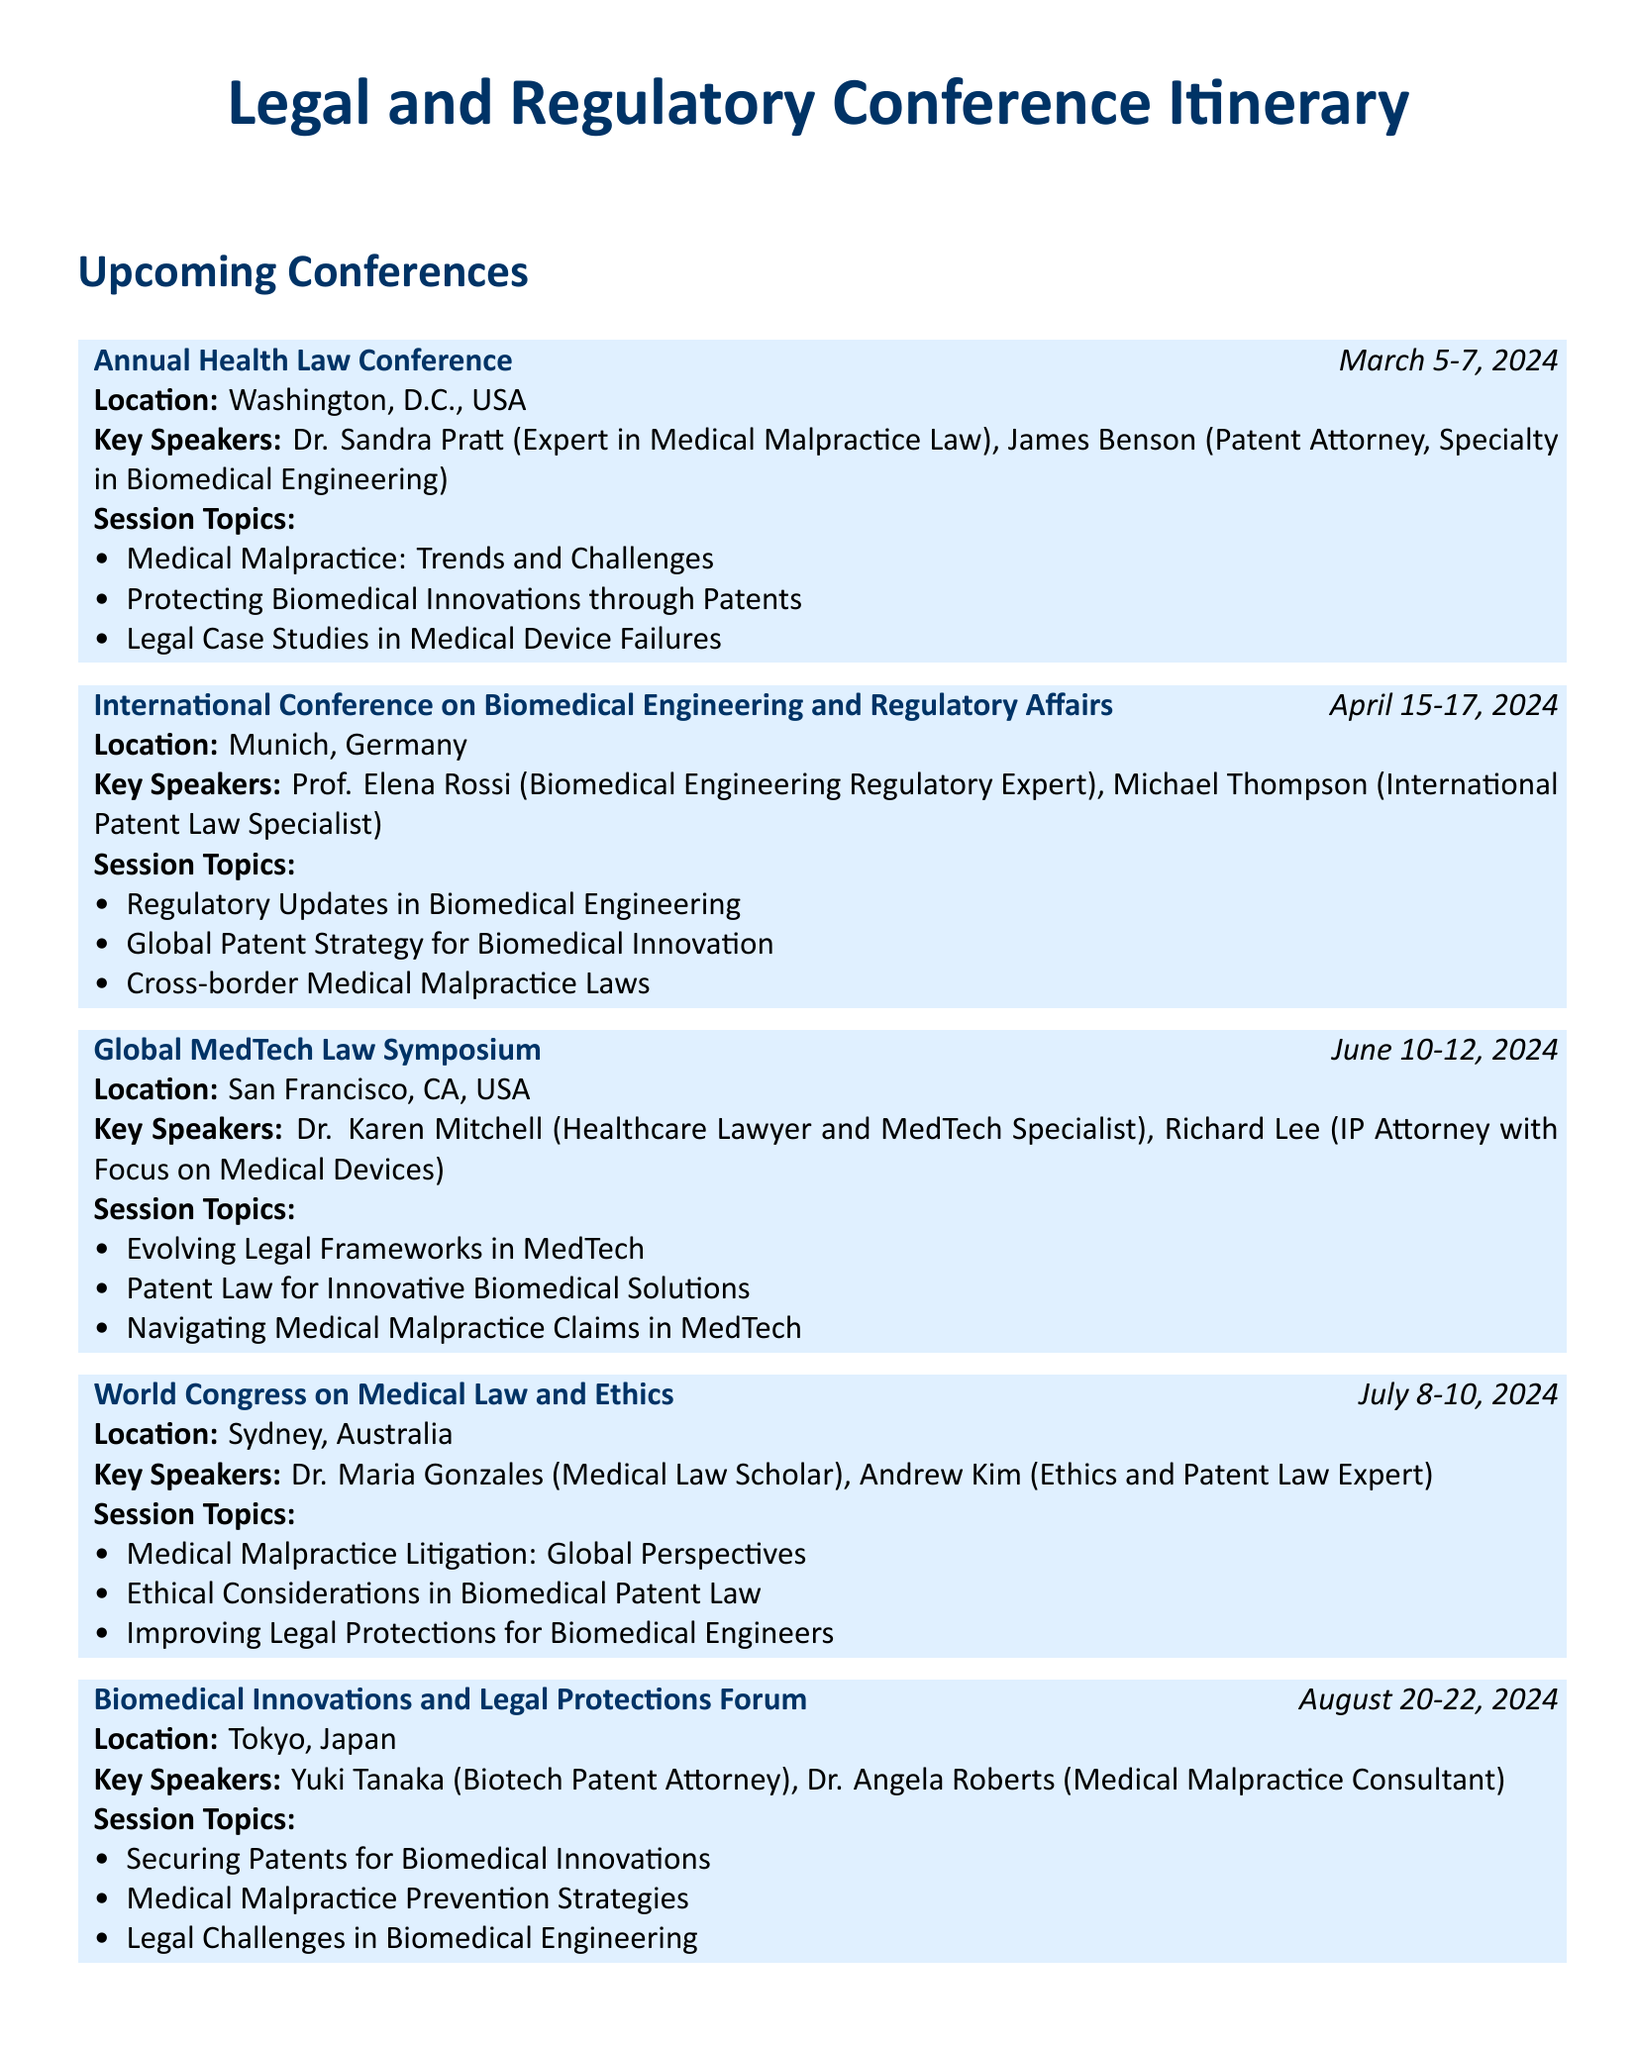What is the date of the Annual Health Law Conference? The date is specified in the document as March 5-7, 2024.
Answer: March 5-7, 2024 Where will the International Conference on Biomedical Engineering and Regulatory Affairs be held? The location is mentioned in the document, which is Munich, Germany.
Answer: Munich, Germany Who is a key speaker at the Global MedTech Law Symposium? The document lists Dr. Karen Mitchell as a key speaker for the symposium.
Answer: Dr. Karen Mitchell What is one of the session topics at the World Congress on Medical Law and Ethics? The document provides several topics, one being Medical Malpractice Litigation: Global Perspectives.
Answer: Medical Malpractice Litigation: Global Perspectives How many days does the Biomedical Innovations and Legal Protections Forum last? The duration is indicated in the document as three days, from August 20-22, 2024.
Answer: Three days Which conference focuses on ethical considerations in biomedical patent law? The document specifies this topic as part of the World Congress on Medical Law and Ethics.
Answer: World Congress on Medical Law and Ethics What is the main subject of the session titled "Protecting Biomedical Innovations through Patents"? The main subject relates to patent law, as indicated by its title in the conference sessions.
Answer: Patent law Who are the two speakers featured at the Annual Health Law Conference? The document lists Dr. Sandra Pratt and James Benson as speakers.
Answer: Dr. Sandra Pratt, James Benson What is the location of the Global MedTech Law Symposium? The document explicitly states it to be San Francisco, CA, USA.
Answer: San Francisco, CA, USA 